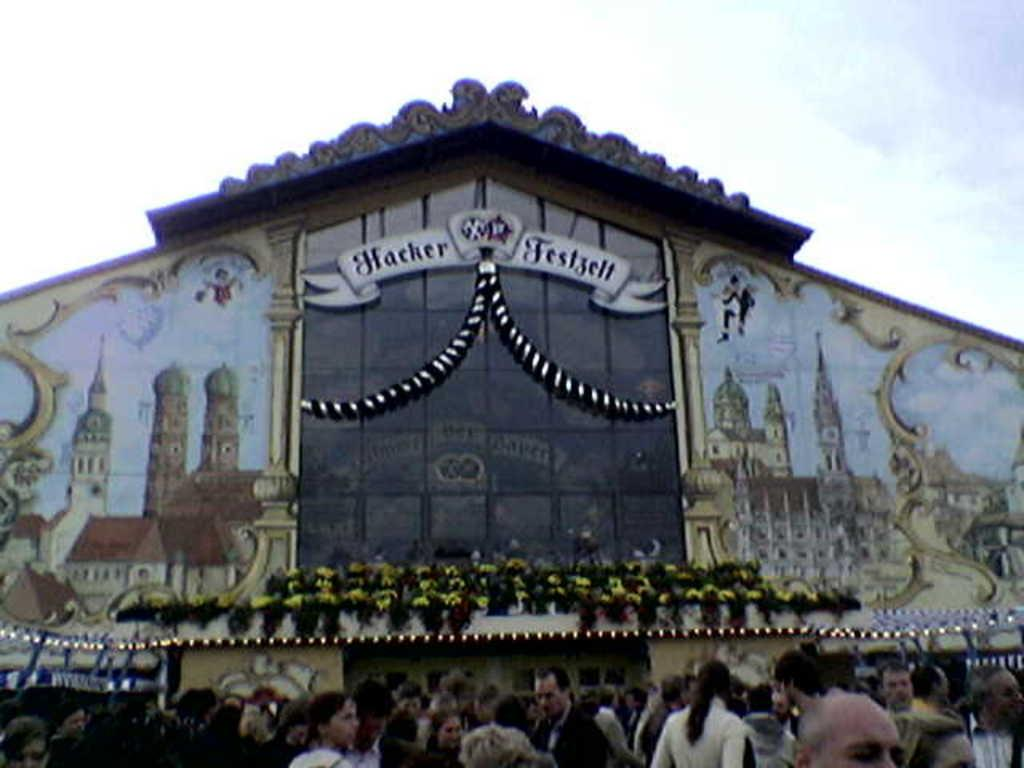<image>
Summarize the visual content of the image. Many people are outside the Hacker Festjelt building. 